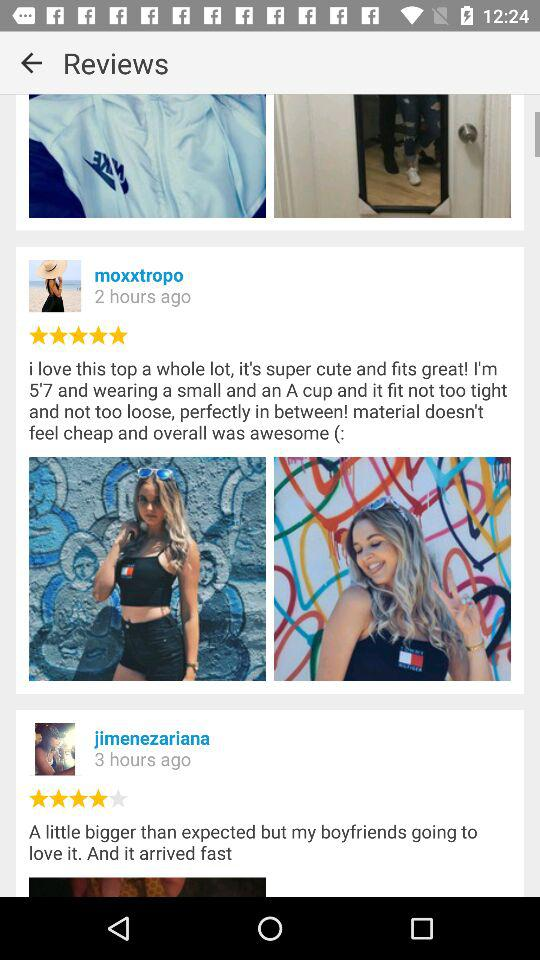How many hours ago did Moxxtropo update a post? Moxxtropo updated a post 2 hours ago. 